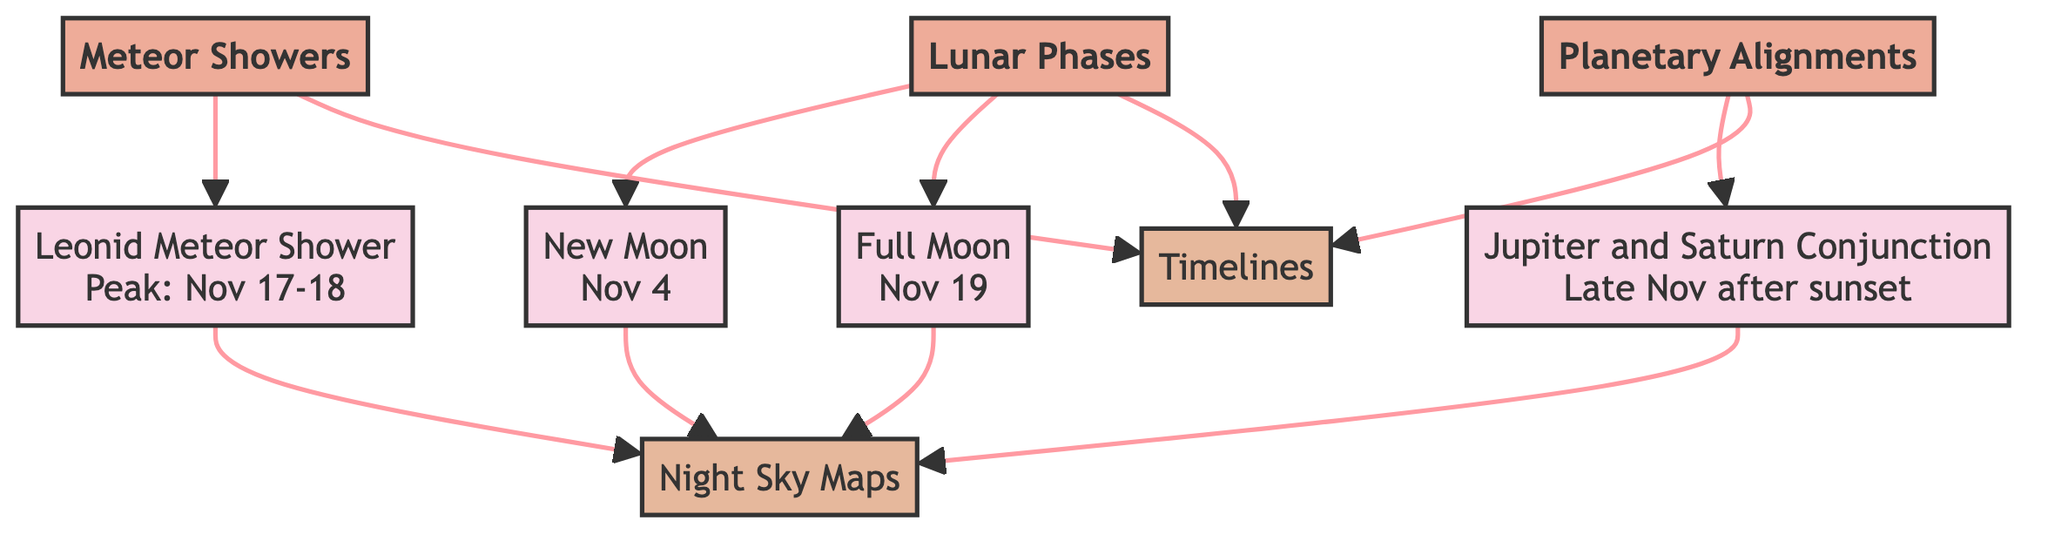What celestial event peaks on November 17-18? The diagram shows that the Leonid Meteor Shower peaks on November 17-18, clearly indicating it under the Meteor Showers category.
Answer: Leonid Meteor Shower What phase does the moon reach on November 4? The diagram specifies that the New Moon occurs on November 4, which is detailed under the Lunar Phases category.
Answer: New Moon How many categories are represented in the diagram? The diagram includes three distinct categories: Meteor Showers, Lunar Phases, and Planetary Alignments, making a total of three.
Answer: 3 What notable planetary event occurs in late November? The diagram indicates that there is a Jupiter and Saturn conjunction that takes place late in November after sunset, as listed under Planetary Alignments.
Answer: Jupiter and Saturn Conjunction How many lunar phases are represented in the diagram? There are two lunar phases depicted: New Moon on November 4 and Full Moon on November 19, making a total of two lunar phases in the diagram.
Answer: 2 Which visual elements are attached to the events? The diagram links both Night Sky Maps and Timelines to each event category, demonstrating that these visual elements are connected to the events listed.
Answer: Night Sky Maps and Timelines What is the relationship between the Leonid Meteor Shower and visual elements? The Leonid Meteor Shower is connected to both Night Sky Maps and Timelines, indicating that viewers can reference these resources during the event.
Answer: Night Sky Maps and Timelines What phase does the moon reach on November 19? The Full Moon occurs on November 19, which is specified under the Lunar Phases category in the diagram.
Answer: Full Moon 